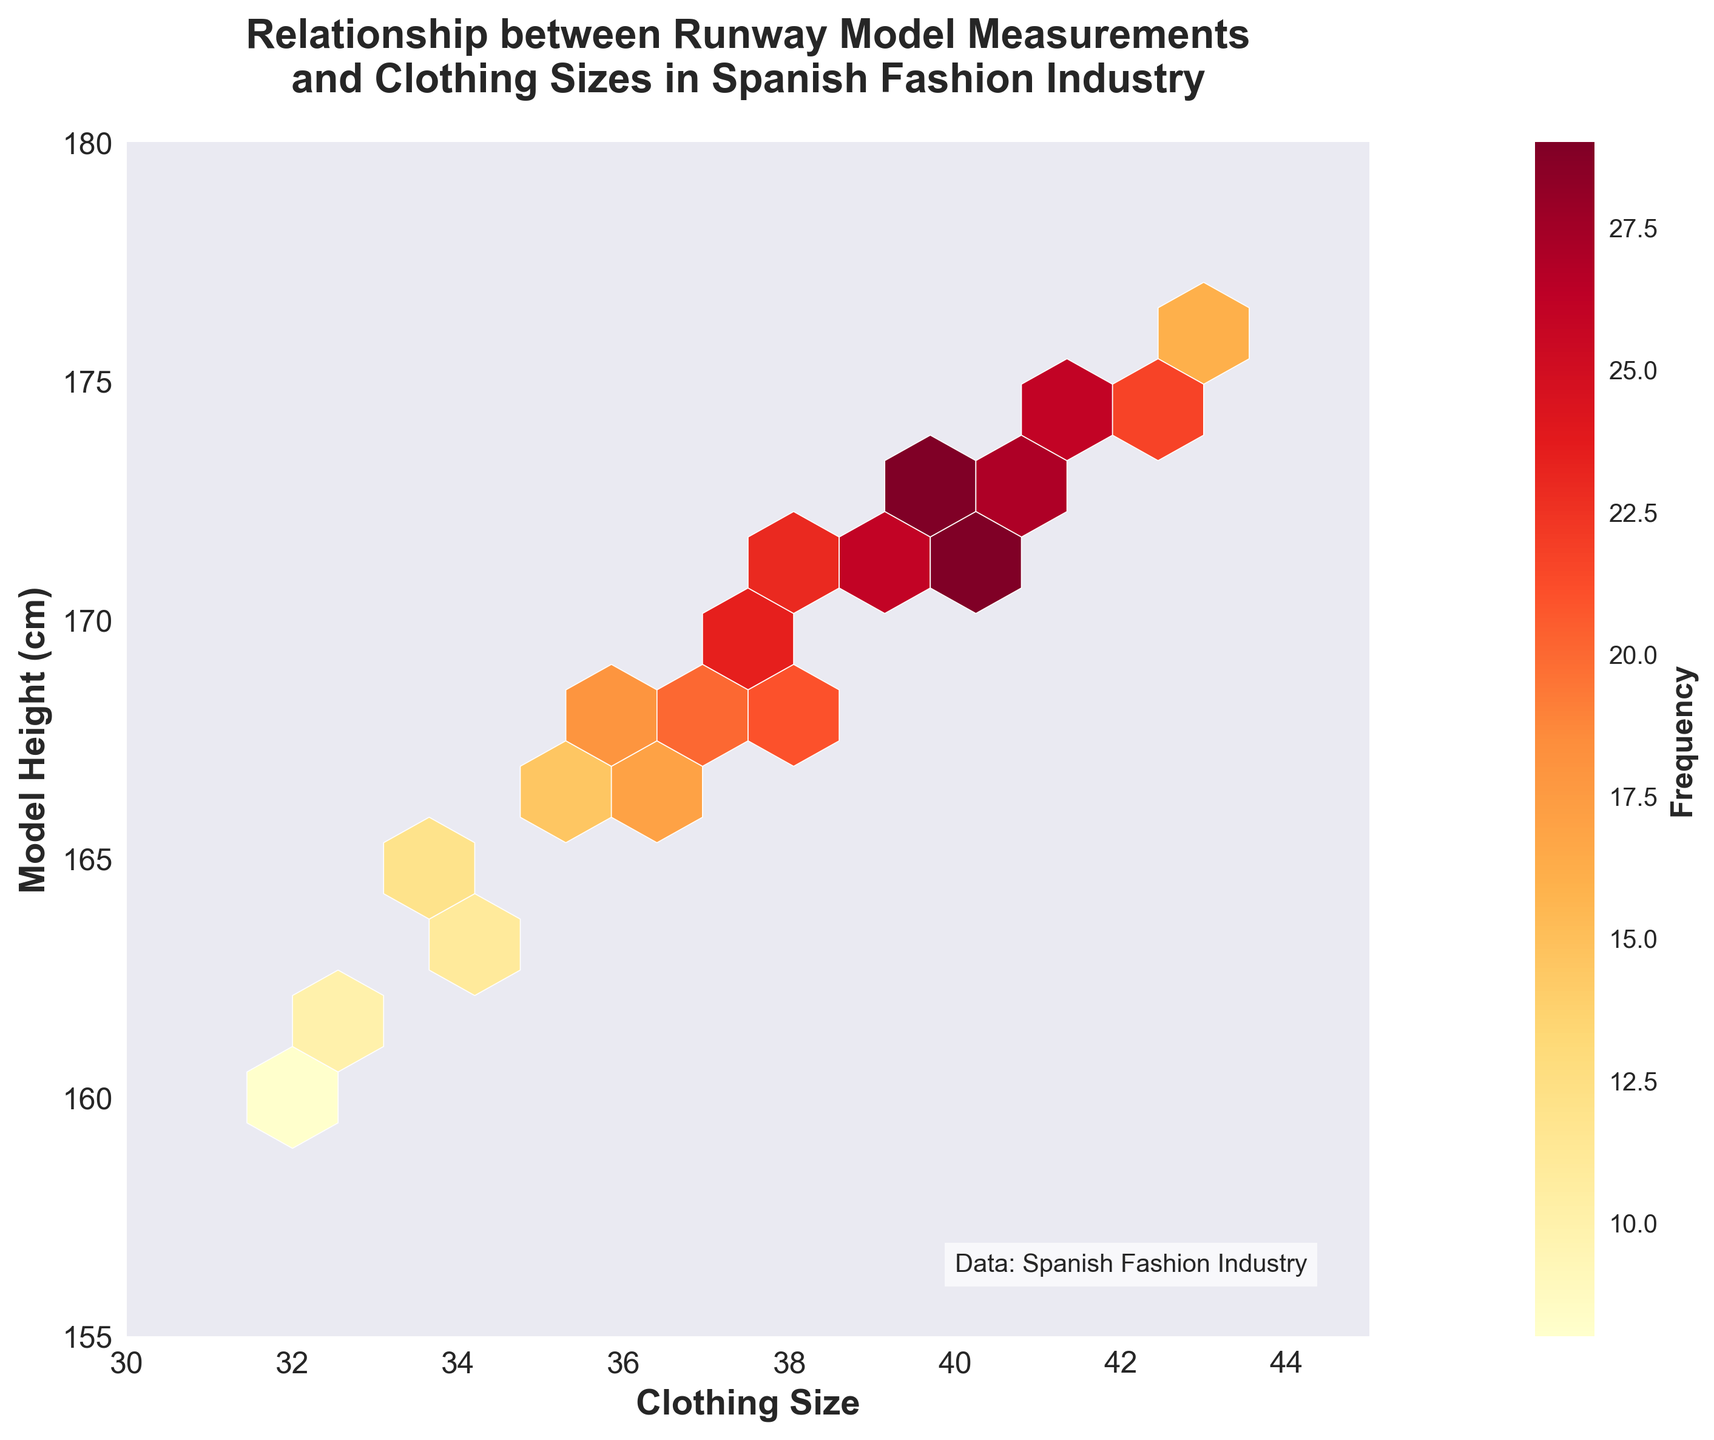What is the title of the hexbin plot? The title of the plot is written visibly at the top.
Answer: Relationship between Runway Model Measurements and Clothing Sizes in Spanish Fashion Industry What are the ranges of the x-axis and y-axis? The x-axis and y-axis ranges are given within the plot boundaries. The x-axis ranges from 30 to 45, and the y-axis ranges from 155 to 180.
Answer: x: 30-45, y: 155-180 What does the color scale indicate in the plot? The color scale, denoted by the color bar on the right, indicates the frequency of data points within each hexbin. The brighter the color, the higher the frequency.
Answer: Frequency of data points Which clothing size corresponds with the highest frequency for model heights around 172-173 cm? By observing the hexagons and their colors, the brightest hexagons (which are around 172-173 cm height) occur at clothing sizes 39 and 40.
Answer: Sizes 39 and 40 How does the frequency change as model height increases from 160 cm to 175 cm for clothing sizes 32 and 42? By tracking the color intensity changes along these heights for sizes 32 and 42, we see that from 160 cm to 175 cm, the frequency for size 32 starts at a lighter shade indicating a lower frequency, whereas for size 42, the color becomes brighter indicating an increasing frequency.
Answer: Size 32: lower frequency to same; Size 42: increasing frequency Is there a visible trend between model height and clothing size? Observing the hexbin plot, there’s a noticeable trend where higher model heights correspond with larger clothing sizes.
Answer: Yes What is the frequency at the hexbin where clothing size is 40 and model height is 173 cm? The hexbin at size 40 and height 173 cm is quite bright. Refer to the color bar to get the approximate frequency.
Answer: Around 30 Are there more data points for models of height 170 cm or 175 cm? By inspecting the color density at these heights across the plot, height 170 cm has darker and more numerous hexagons compared to height 175 cm.
Answer: 170 cm Which size-height combination shows the most variety in terms of frequency? The spread of colors in hexagons across an area indicates variety. Between 36-38 size and 168-170 cm height, there is significant variation in color density.
Answer: Sizes 36-38, Heights 168-170 cm Do model measurements between 160 cm and 165 cm show a significant frequency? Observing the plot, model heights between 160 cm and 165 cm show relatively lighter colors, indicating lower frequencies.
Answer: No What is the frequency for the clothing size 36 and model height 167 cm? Observing the corresponding hexagon and matching its color to the color bar, the frequency appears to be around 17.
Answer: 17 